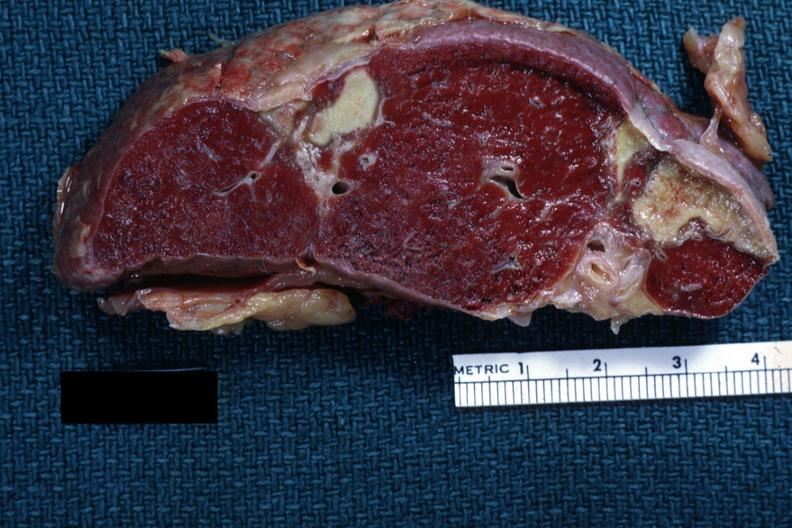s hemorrhage in newborn present?
Answer the question using a single word or phrase. No 